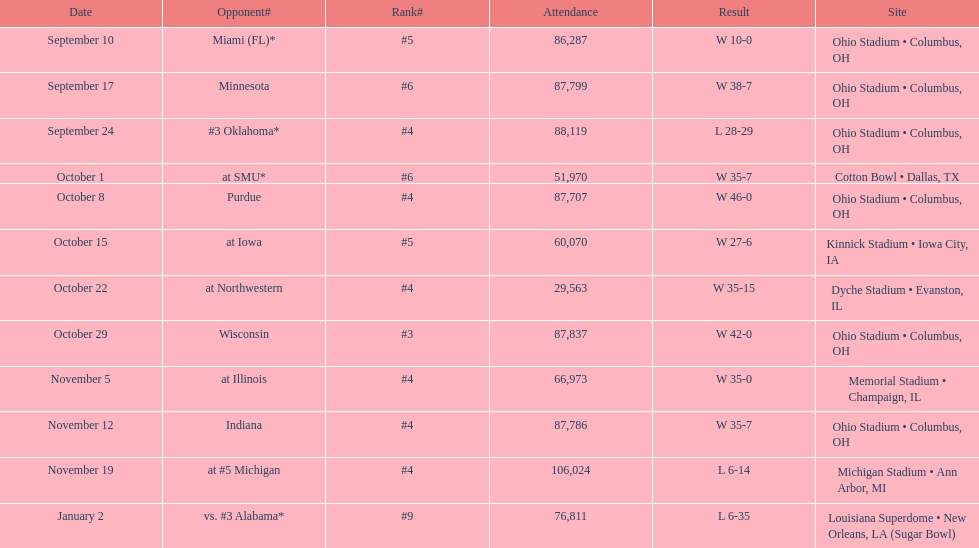How many dates are on the chart 12. 